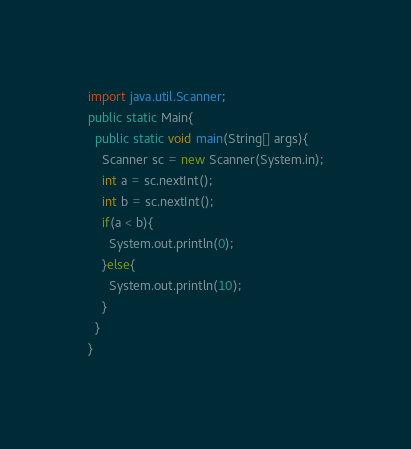<code> <loc_0><loc_0><loc_500><loc_500><_Java_>import java.util.Scanner;
public static Main{
  public static void main(String[] args){
    Scanner sc = new Scanner(System.in);
    int a = sc.nextInt();
    int b = sc.nextInt();
    if(a < b){
      System.out.println(0);
    }else{
      System.out.println(10);      
    }
  }
}</code> 